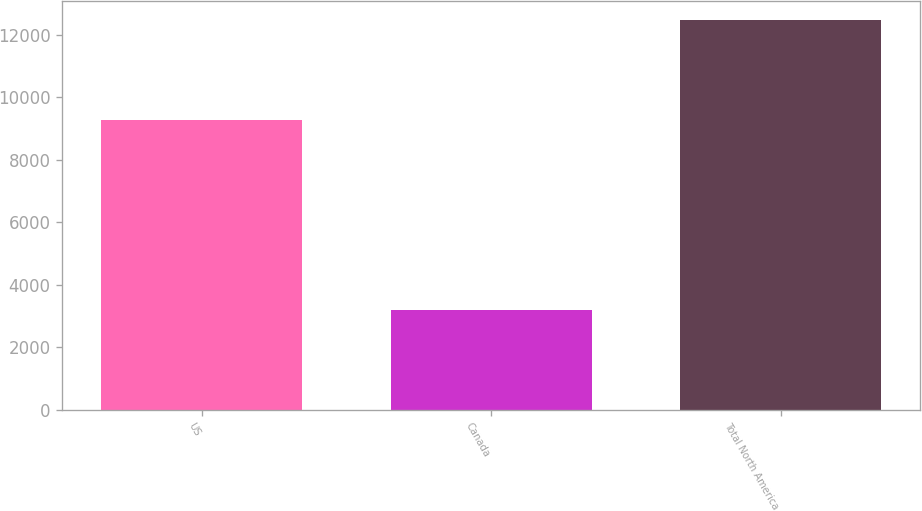Convert chart. <chart><loc_0><loc_0><loc_500><loc_500><bar_chart><fcel>US<fcel>Canada<fcel>Total North America<nl><fcel>9284<fcel>3183<fcel>12467<nl></chart> 